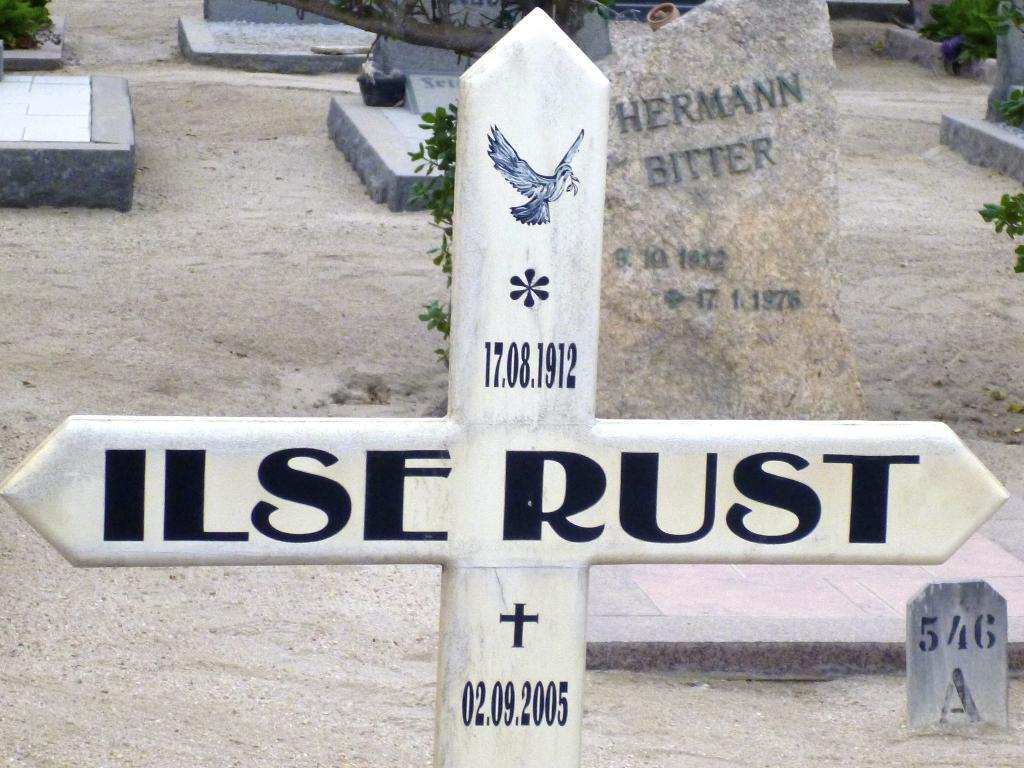What is the main symbol in the foreground of the image? There is a cross symbol in the foreground of the image. What can be seen in the background of the image? There are headstones in the background of the image. What type of vegetation is present on the ground in the image? Greenery is present on the ground in the image. Where is the lunchroom located in the image? There is no lunchroom present in the image. Can you describe the hand gestures of the people in the image? There are no people present in the image, so hand gestures cannot be described. 